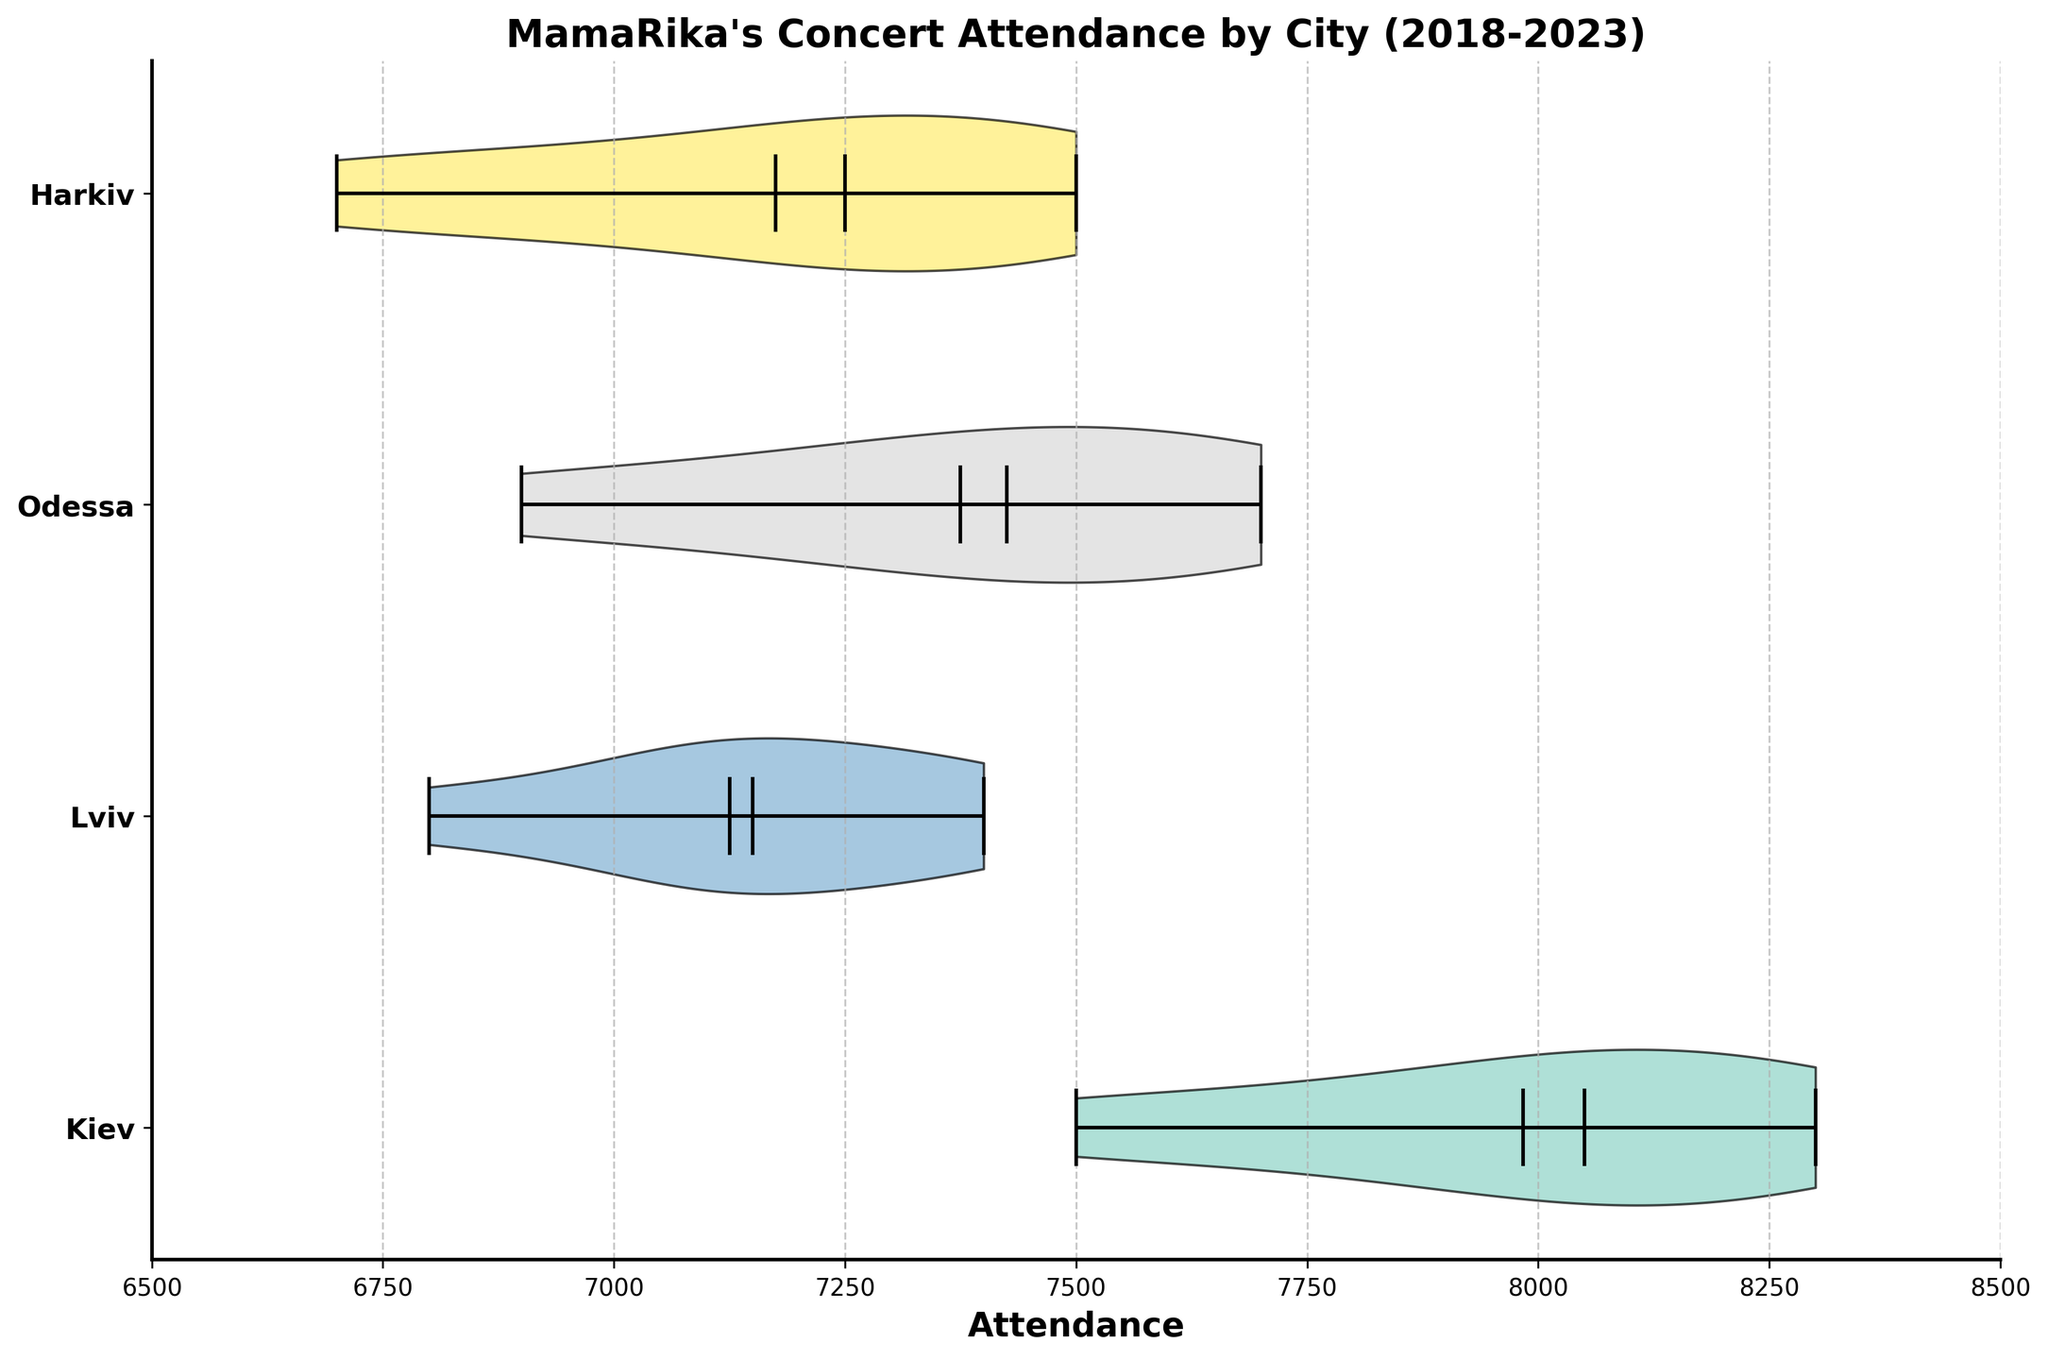What is the title of the figure? The title is displayed prominently at the top of the figure. It provides a summary of what the figure represents.
Answer: "MamaRika's Concert Attendance by City (2018-2023)" What is the median attendance for concerts in Kiev? The median value is displayed on the violin plot as a central marker. Look for the marker in the violin plot corresponding to Kiev.
Answer: 8000 How many cities are represented in the figure? Each horizontal strip in the violin plot corresponds to a city. Count the number of horizontal strips.
Answer: 4 Which city has the highest mean attendance? The mean value is represented by a marker in each violin plot. Compare these markers across all cities to identify the highest one.
Answer: Kiev Is the spread of attendance values wider in Lviv or Odessa? The spread is indicated by the width of the violin plot. Compare the width of the violin plots for Lviv and Odessa.
Answer: Lviv What is the lowest attendance recorded, and for which city? The minimum attendance is represented at the bottom edge of each violin plot. Find the lowest point among all cities.
Answer: 6700, Harkiv Between which two cities is there the smallest difference in median attendance? Compare the median attendance values (central markers) for pairs of cities and identify the pair with the smallest difference.
Answer: Odessa and Harkiv Which city shows the most variability in concert attendance? Variability is represented by the spread (width) of the violin plot. The city with the widest plot has the most variability.
Answer: Harkiv How does the range of attendance values in Kiev compare to that in Lviv? Calculate the range for each city by subtracting the lowest value from the highest value in each violin plot and compare these ranges.
Answer: Kiev: 8300 - 7500 = 800, Lviv: 7400 - 6800 = 600 What are the quartile ranges for Odessa? The quartiles split the attendance data into four equal parts. They are displayed in the violin plot. Divide the entire violin plot range into four equal sections and identify the attendance ranges.
Answer: 6900-7100, 7100-7350, 7350-7600, 7600-8000 